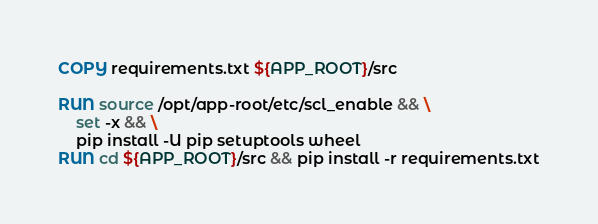<code> <loc_0><loc_0><loc_500><loc_500><_Dockerfile_>COPY requirements.txt ${APP_ROOT}/src

RUN source /opt/app-root/etc/scl_enable && \
    set -x && \
    pip install -U pip setuptools wheel
RUN cd ${APP_ROOT}/src && pip install -r requirements.txt
</code> 